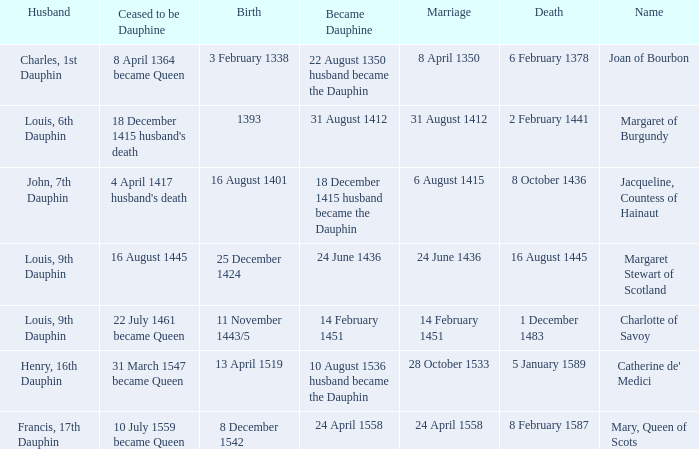When was became dauphine when birth is 1393? 31 August 1412. 